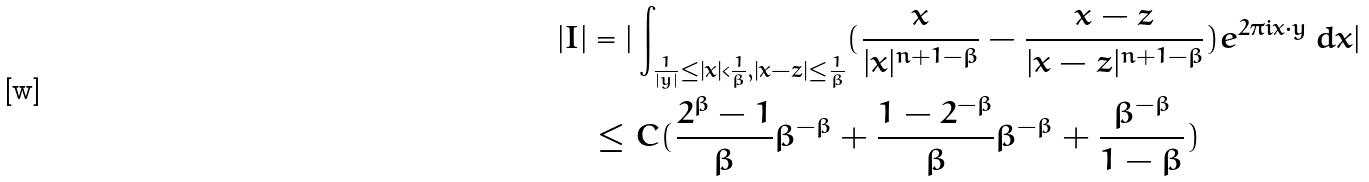<formula> <loc_0><loc_0><loc_500><loc_500>| I | & = | \int _ { \frac { 1 } { | y | } \leq | x | < \frac { 1 } { \beta } , | x - z | \leq \frac { 1 } { \beta } } ( \frac { x } { | x | ^ { n + 1 - \beta } } - \frac { x - z } { | x - z | ^ { n + 1 - \beta } } ) e ^ { 2 \pi i x \cdot y } \, d x | \\ & \leq C ( \frac { 2 ^ { \beta } - 1 } { \beta } \beta ^ { - \beta } + \frac { 1 - 2 ^ { - \beta } } { \beta } \beta ^ { - \beta } + \frac { \beta ^ { - \beta } } { 1 - \beta } )</formula> 